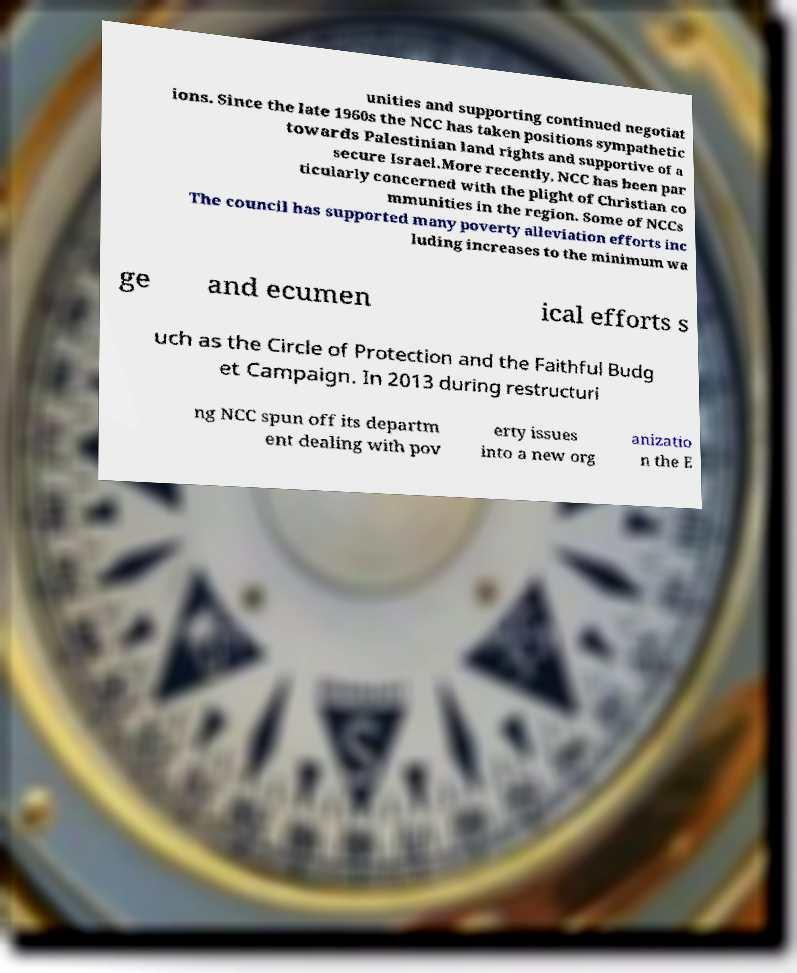Please read and relay the text visible in this image. What does it say? unities and supporting continued negotiat ions. Since the late 1960s the NCC has taken positions sympathetic towards Palestinian land rights and supportive of a secure Israel.More recently, NCC has been par ticularly concerned with the plight of Christian co mmunities in the region. Some of NCCs The council has supported many poverty alleviation efforts inc luding increases to the minimum wa ge and ecumen ical efforts s uch as the Circle of Protection and the Faithful Budg et Campaign. In 2013 during restructuri ng NCC spun off its departm ent dealing with pov erty issues into a new org anizatio n the E 